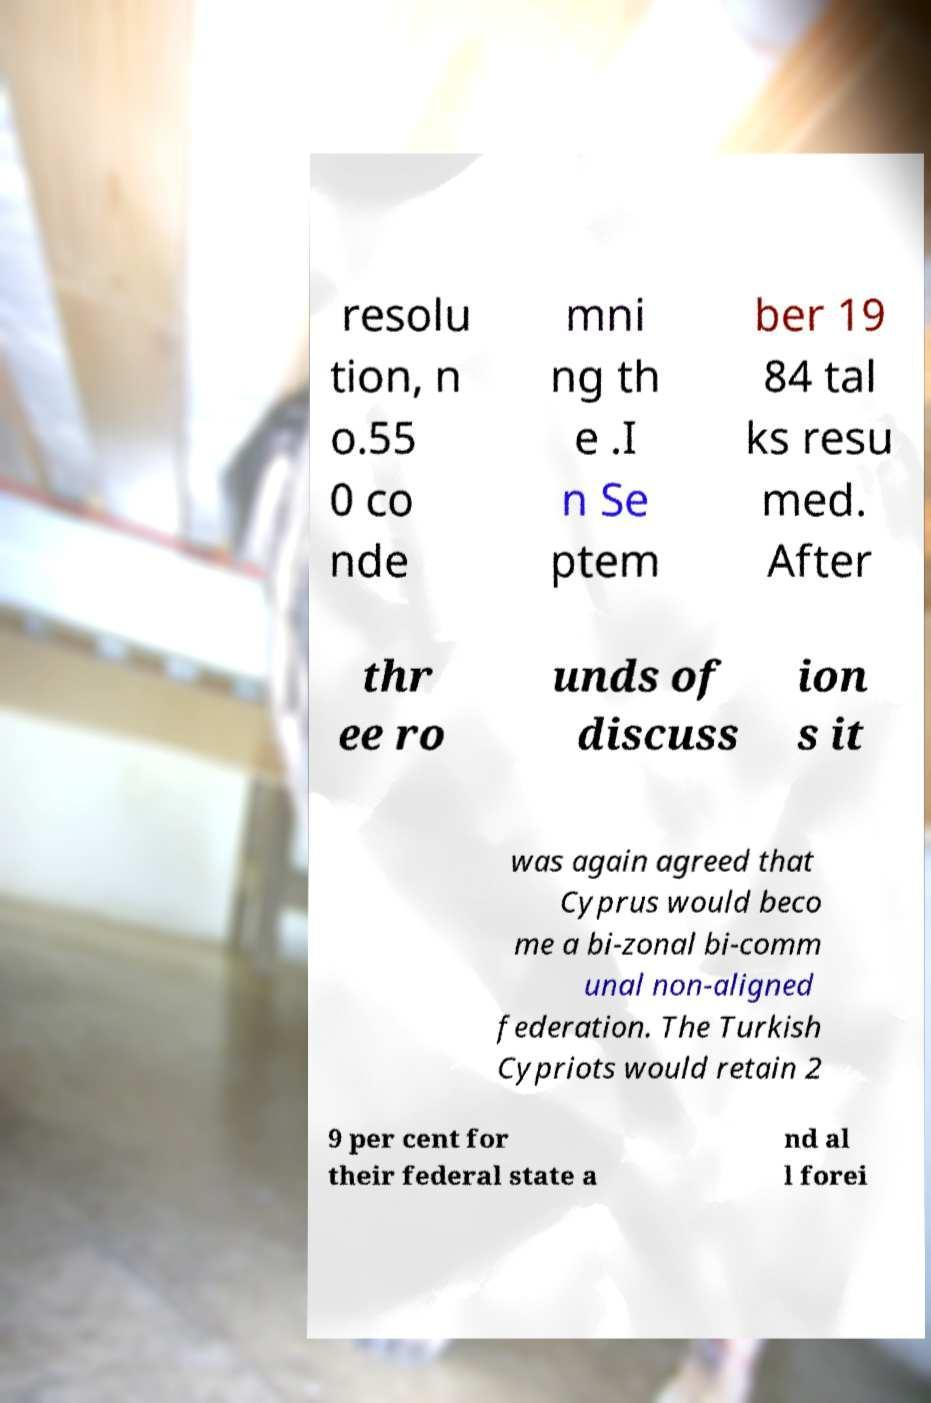Please identify and transcribe the text found in this image. resolu tion, n o.55 0 co nde mni ng th e .I n Se ptem ber 19 84 tal ks resu med. After thr ee ro unds of discuss ion s it was again agreed that Cyprus would beco me a bi-zonal bi-comm unal non-aligned federation. The Turkish Cypriots would retain 2 9 per cent for their federal state a nd al l forei 